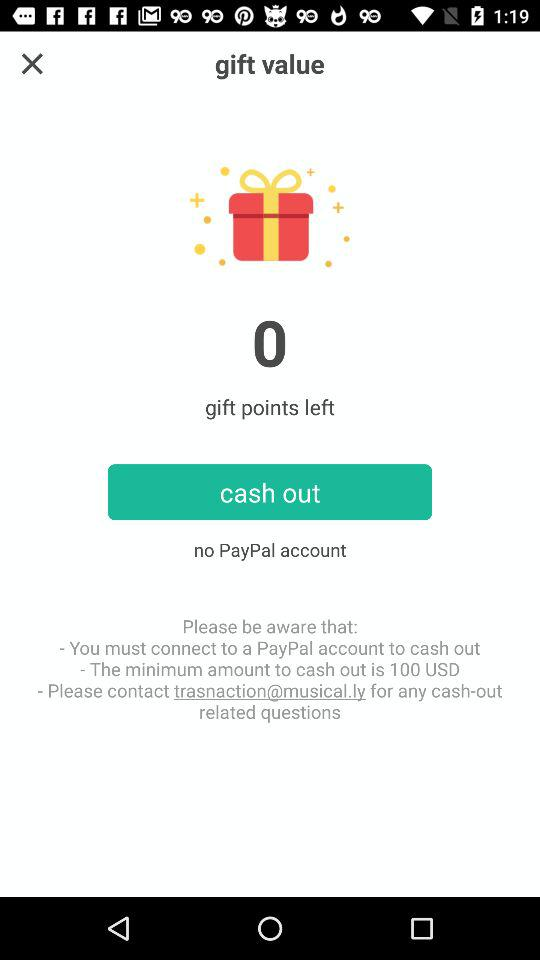How many dollars is the minimum amount to cash out?
Answer the question using a single word or phrase. 100 